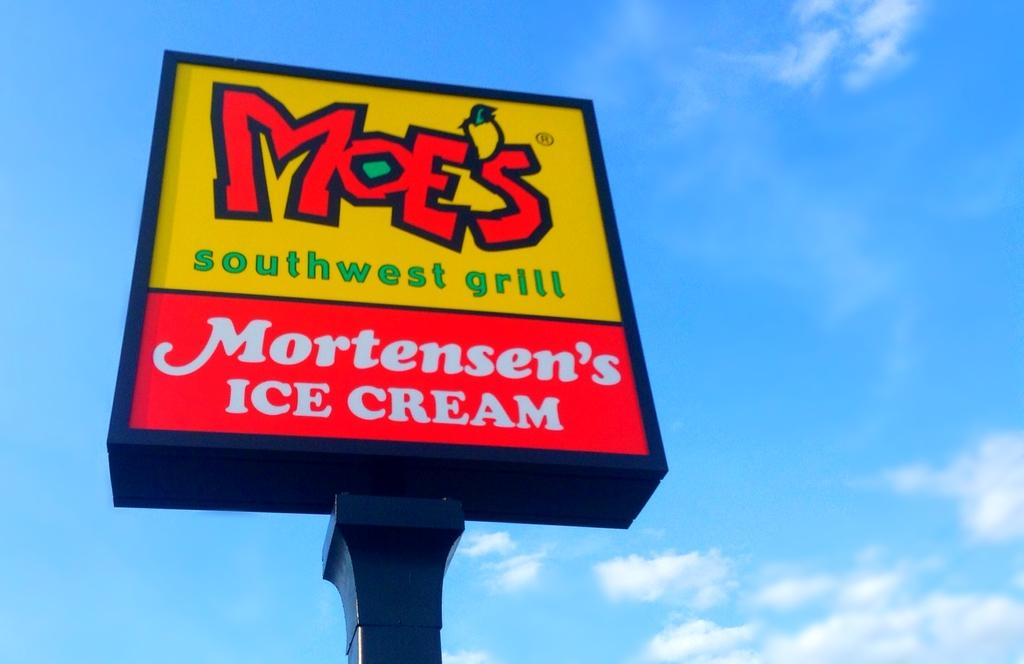<image>
Give a short and clear explanation of the subsequent image. The sign for Moe's southwest grill indicates that they serve Mortensen's ice cream. 